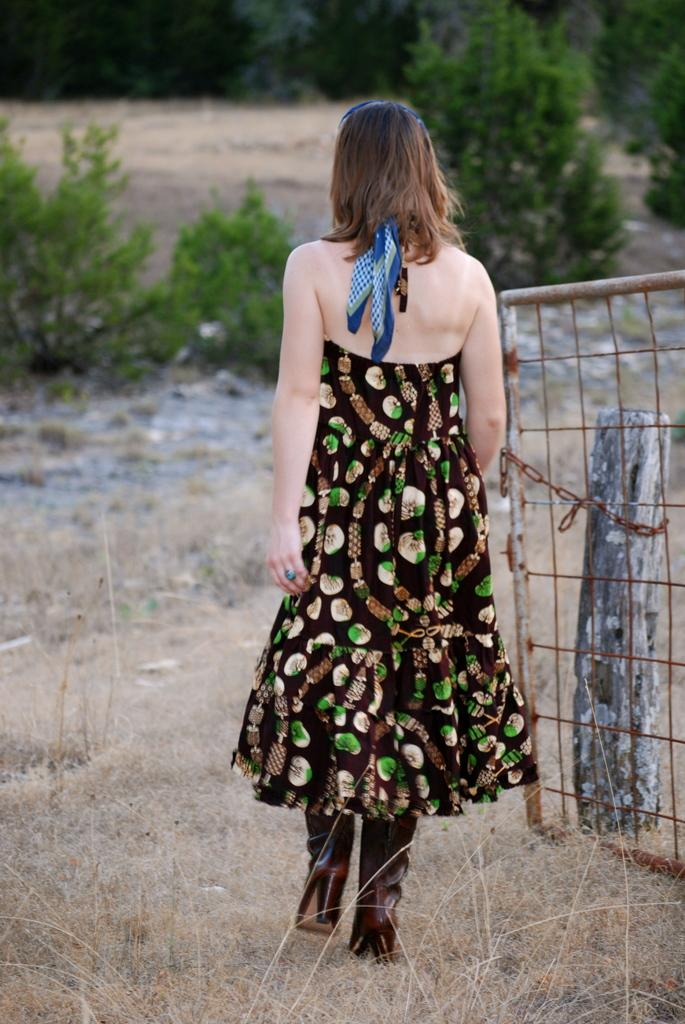Who is present in the image? There is a lady in the image. What is near the lady in the image? There is a gate with a chain in the image. What can be seen in the background of the image? There are trees in the background of the image. What type of ground is visible in the image? There is grass on the ground in the image. What type of vegetable is being used to hold the gate closed in the image? There is no vegetable present in the image, and the gate is not being held closed by any object. 